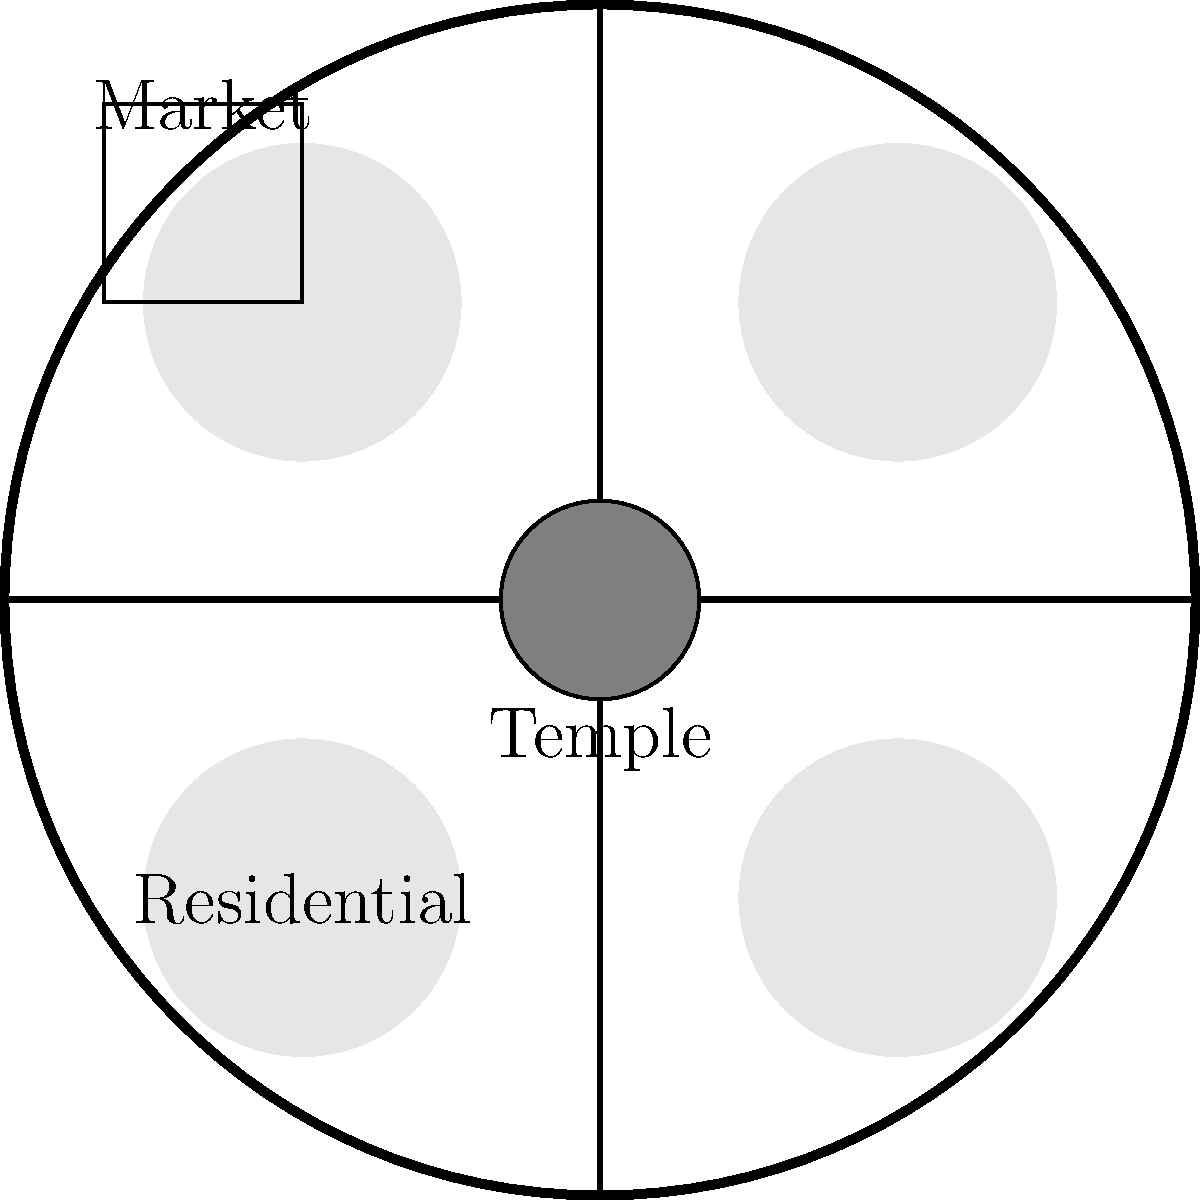In the urban planning of ancient Jewish communities, what was the significance of placing the Temple at the center of the city, as shown in the diagram? How did this central placement influence the social and religious dynamics of the community? 1. Central location: The Temple's placement at the city center reflects its paramount importance in Jewish life and culture.

2. Accessibility: This central position ensures that the Temple is equally accessible to all residents, symbolizing its role as the heart of the community.

3. Urban layout: The city is organized around the Temple, with main roads leading to it, facilitating pilgrimage and daily worship.

4. Social cohesion: The central Temple serves as a unifying force, bringing people together for religious observances and communal activities.

5. Spiritual focus: This layout constantly reminds inhabitants of their religious duties and the presence of the divine in their midst.

6. Economic impact: The Temple's central location likely influenced the placement of markets and other commercial activities nearby.

7. Security: Positioning the Temple at the center provides it with maximum protection, surrounded by the city's defenses.

8. Cosmological significance: This layout may represent the Jewish view of the Temple as the center of the world, connecting heaven and earth.

9. Cultural identity: The prominent placement of the Temple reinforces Jewish identity and distinguishes the city as a Jewish settlement.

10. Educational role: The central Temple serves as a focal point for religious education and the transmission of Jewish traditions.
Answer: The Temple's central placement symbolizes its spiritual, social, and cultural centrality, influencing community cohesion, urban design, and religious practice. 